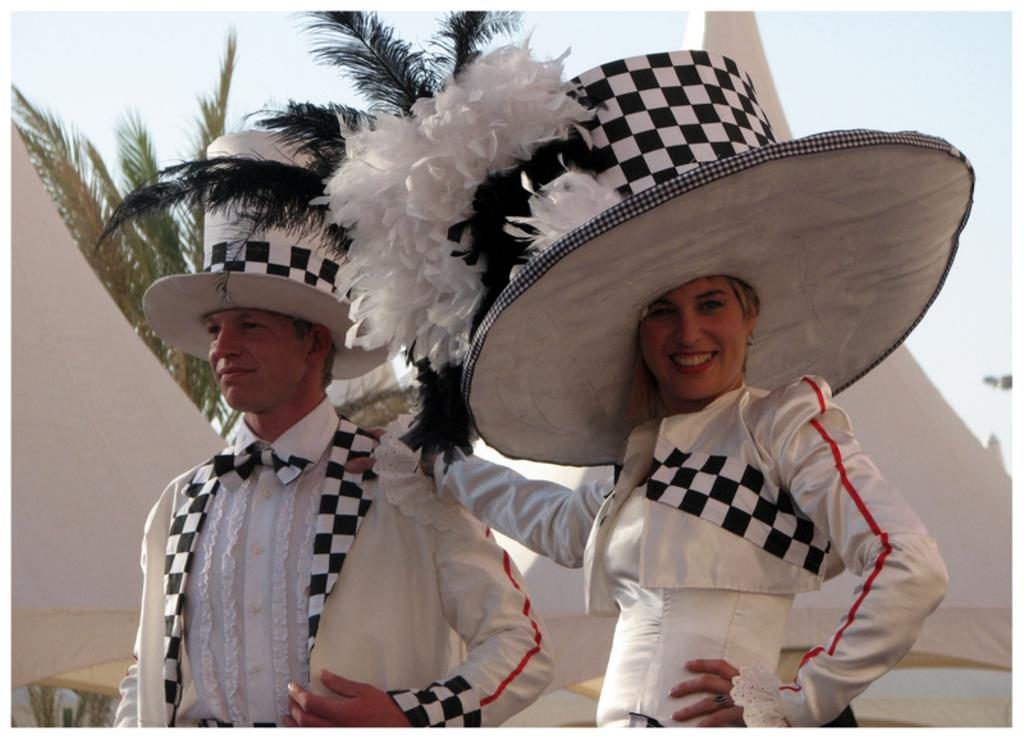How many people are in the foreground of the image? There are two persons in the foreground of the image. What are the persons wearing? The persons are wearing costumes. What can be seen in the background of the image? There are trees, tents, and the sky visible in the background of the image. What time of day was the image likely taken? The image was likely taken during the day, as the sky is visible. What type of lace can be seen on the costumes of the persons in the image? There is no mention of lace on the costumes in the provided facts, so we cannot determine if lace is present or its type. What historical event is being depicted in the image? There is no information about a historical event or its depiction in the provided facts, so we cannot determine if any historical event is being depicted. 